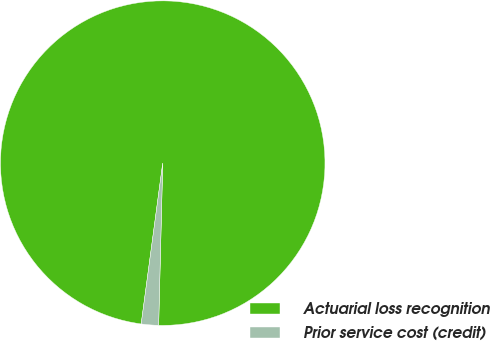Convert chart to OTSL. <chart><loc_0><loc_0><loc_500><loc_500><pie_chart><fcel>Actuarial loss recognition<fcel>Prior service cost (credit)<nl><fcel>98.28%<fcel>1.72%<nl></chart> 